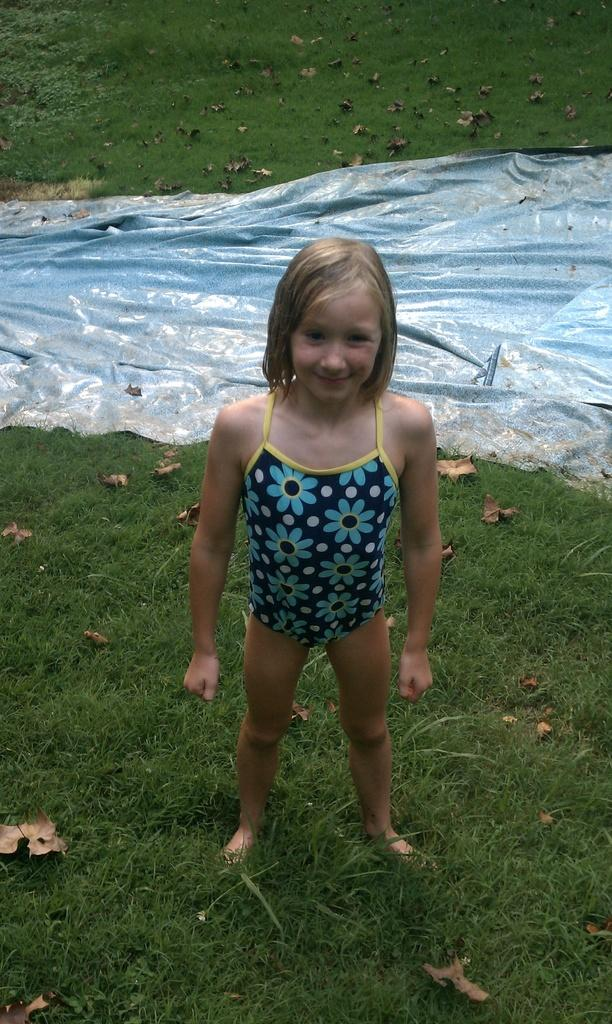What type of natural material can be seen in the image? There are dried leaves in the image. What type of covering is present in the image? There is tarpaulin in the image. What color is the grass in the image? The grass in the image is green. Can you describe the person in the image? There is a person standing in the image, and they are smiling. What type of lead is the person holding in the image? There is no lead present in the image. Can you tell me how many celery stalks are visible in the image? There is no celery present in the image. 